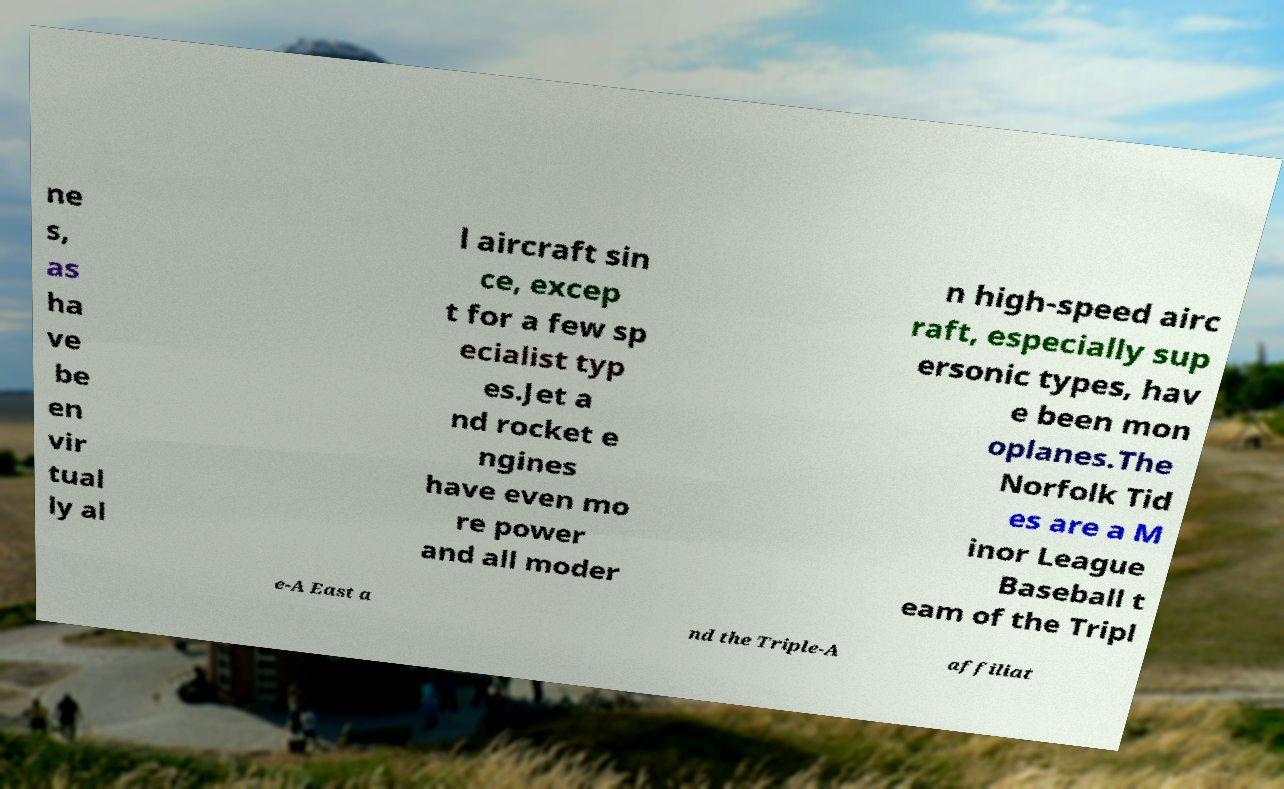For documentation purposes, I need the text within this image transcribed. Could you provide that? ne s, as ha ve be en vir tual ly al l aircraft sin ce, excep t for a few sp ecialist typ es.Jet a nd rocket e ngines have even mo re power and all moder n high-speed airc raft, especially sup ersonic types, hav e been mon oplanes.The Norfolk Tid es are a M inor League Baseball t eam of the Tripl e-A East a nd the Triple-A affiliat 